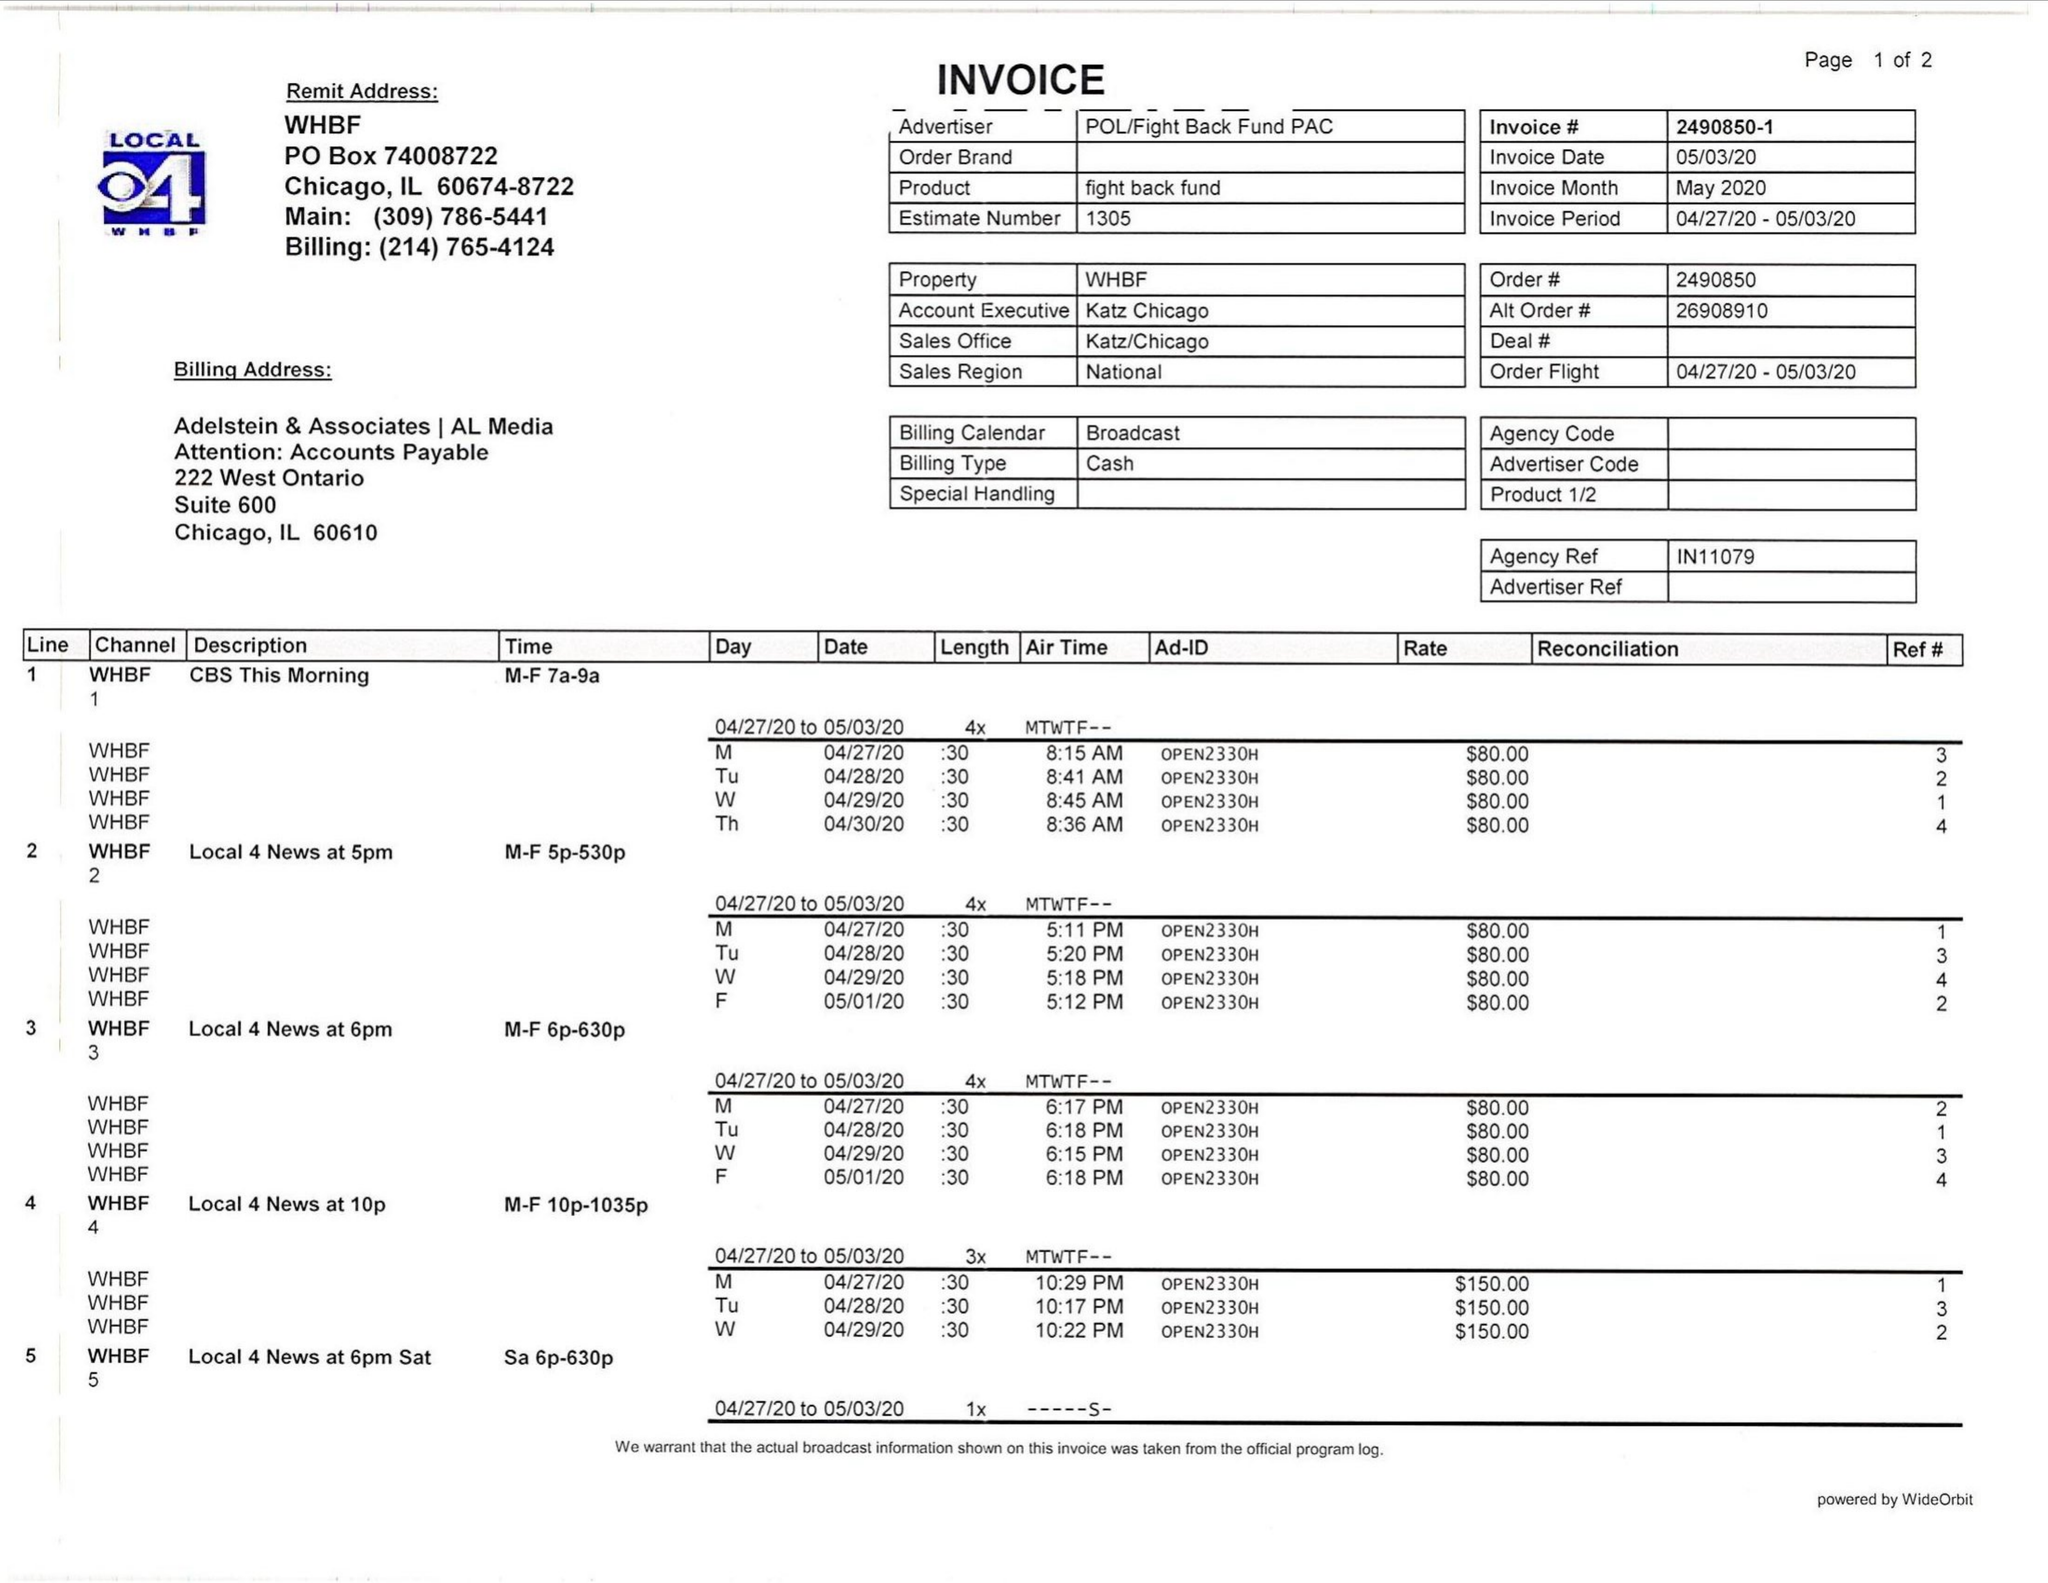What is the value for the contract_num?
Answer the question using a single word or phrase. 2490850 